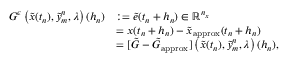<formula> <loc_0><loc_0><loc_500><loc_500>\begin{array} { r l } { G ^ { \epsilon } \left ( \tilde { x } ( t _ { n } ) , \tilde { y } _ { m } ^ { n } , \lambda \right ) ( h _ { n } ) } & { \colon = \tilde { e } ( t _ { n } + h _ { n } ) \in \mathbb { R } ^ { n _ { x } } } \\ & { = x ( t _ { n } + h _ { n } ) - \tilde { x } _ { a p p r o x } ( t _ { n } + h _ { n } ) } \\ & { = [ \tilde { G } - \tilde { G } _ { a p p r o x } ] \left ( \tilde { x } ( t _ { n } ) , \tilde { y } _ { m } ^ { n } , \lambda \right ) ( h _ { n } ) , } \end{array}</formula> 